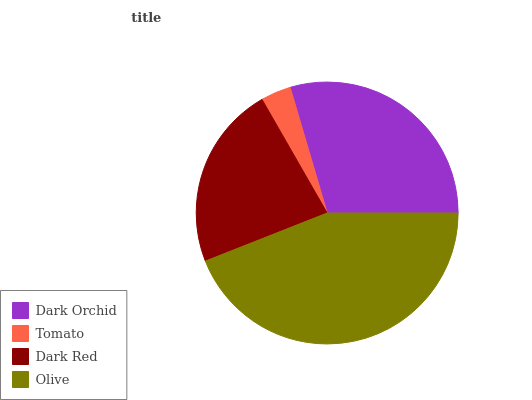Is Tomato the minimum?
Answer yes or no. Yes. Is Olive the maximum?
Answer yes or no. Yes. Is Dark Red the minimum?
Answer yes or no. No. Is Dark Red the maximum?
Answer yes or no. No. Is Dark Red greater than Tomato?
Answer yes or no. Yes. Is Tomato less than Dark Red?
Answer yes or no. Yes. Is Tomato greater than Dark Red?
Answer yes or no. No. Is Dark Red less than Tomato?
Answer yes or no. No. Is Dark Orchid the high median?
Answer yes or no. Yes. Is Dark Red the low median?
Answer yes or no. Yes. Is Olive the high median?
Answer yes or no. No. Is Tomato the low median?
Answer yes or no. No. 